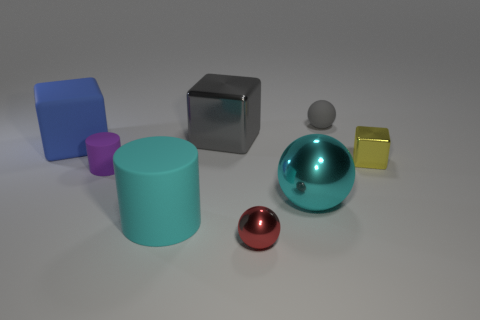Do the sphere behind the large metal sphere and the small metal ball have the same color?
Provide a short and direct response. No. How many things are on the right side of the large blue object and behind the large cyan cylinder?
Keep it short and to the point. 5. There is a gray object that is the same shape as the big blue rubber object; what is its size?
Make the answer very short. Large. There is a shiny cube that is right of the tiny metal object to the left of the big cyan sphere; what number of small purple matte things are behind it?
Your answer should be very brief. 0. What is the color of the small object that is on the right side of the small rubber thing that is right of the tiny purple object?
Provide a short and direct response. Yellow. How many other objects are the same material as the large gray block?
Ensure brevity in your answer.  3. There is a metallic object behind the yellow block; what number of large gray blocks are behind it?
Your answer should be compact. 0. Is there any other thing that is the same shape as the large cyan matte thing?
Offer a very short reply. Yes. There is a tiny sphere in front of the purple cylinder; does it have the same color as the tiny metallic object that is behind the red object?
Keep it short and to the point. No. Are there fewer large red shiny cylinders than small spheres?
Keep it short and to the point. Yes. 